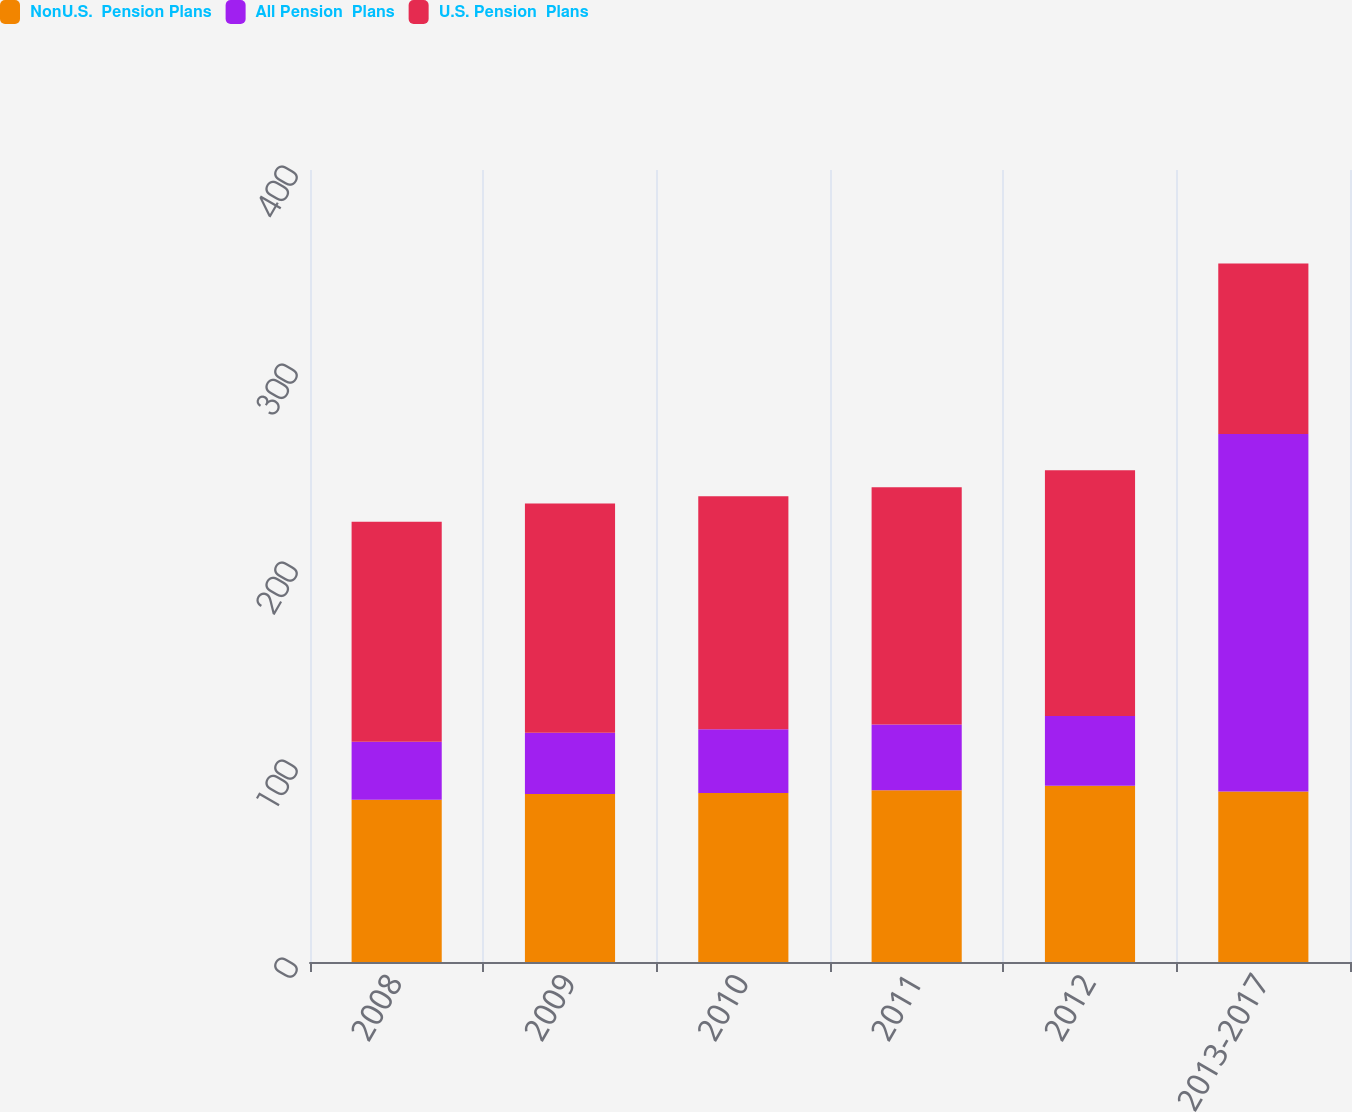Convert chart. <chart><loc_0><loc_0><loc_500><loc_500><stacked_bar_chart><ecel><fcel>2008<fcel>2009<fcel>2010<fcel>2011<fcel>2012<fcel>2013-2017<nl><fcel>NonU.S.  Pension Plans<fcel>82<fcel>84.8<fcel>85.4<fcel>86.8<fcel>89<fcel>86.1<nl><fcel>All Pension  Plans<fcel>29.2<fcel>31<fcel>32.2<fcel>33.1<fcel>35.2<fcel>180.6<nl><fcel>U.S. Pension  Plans<fcel>111.2<fcel>115.8<fcel>117.6<fcel>119.9<fcel>124.2<fcel>86.1<nl></chart> 